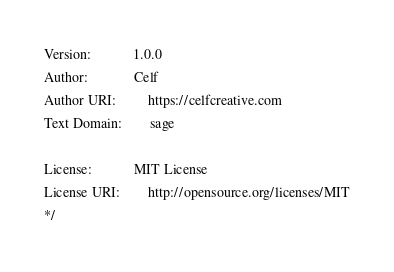<code> <loc_0><loc_0><loc_500><loc_500><_CSS_>Version:            1.0.0
Author:             Celf
Author URI:         https://celfcreative.com
Text Domain:        sage

License:            MIT License
License URI:        http://opensource.org/licenses/MIT
*/
</code> 